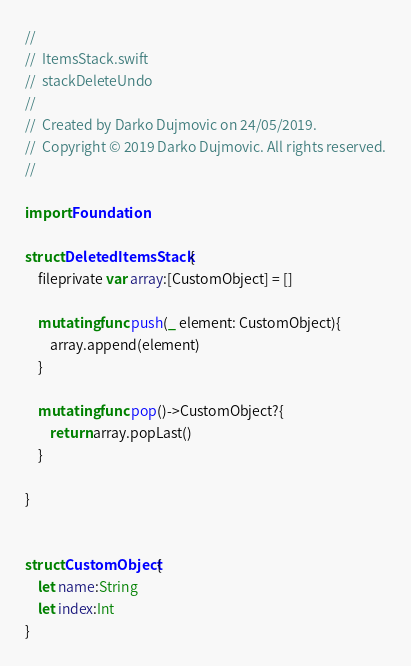Convert code to text. <code><loc_0><loc_0><loc_500><loc_500><_Swift_>//
//  ItemsStack.swift
//  stackDeleteUndo
//
//  Created by Darko Dujmovic on 24/05/2019.
//  Copyright © 2019 Darko Dujmovic. All rights reserved.
//

import Foundation

struct DeletedItemsStack {
    fileprivate var array:[CustomObject] = []
    
    mutating func push(_ element: CustomObject){
        array.append(element)
    }
    
    mutating func pop()->CustomObject?{
        return array.popLast()
    }
    
}


struct CustomObject{
    let name:String
    let index:Int
}
</code> 